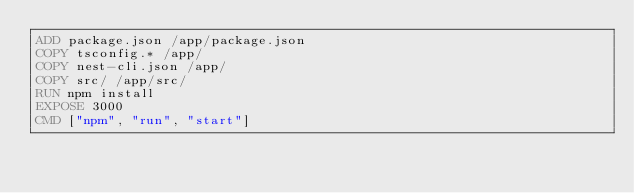Convert code to text. <code><loc_0><loc_0><loc_500><loc_500><_Dockerfile_>ADD package.json /app/package.json
COPY tsconfig.* /app/
COPY nest-cli.json /app/
COPY src/ /app/src/
RUN npm install
EXPOSE 3000
CMD ["npm", "run", "start"]
</code> 